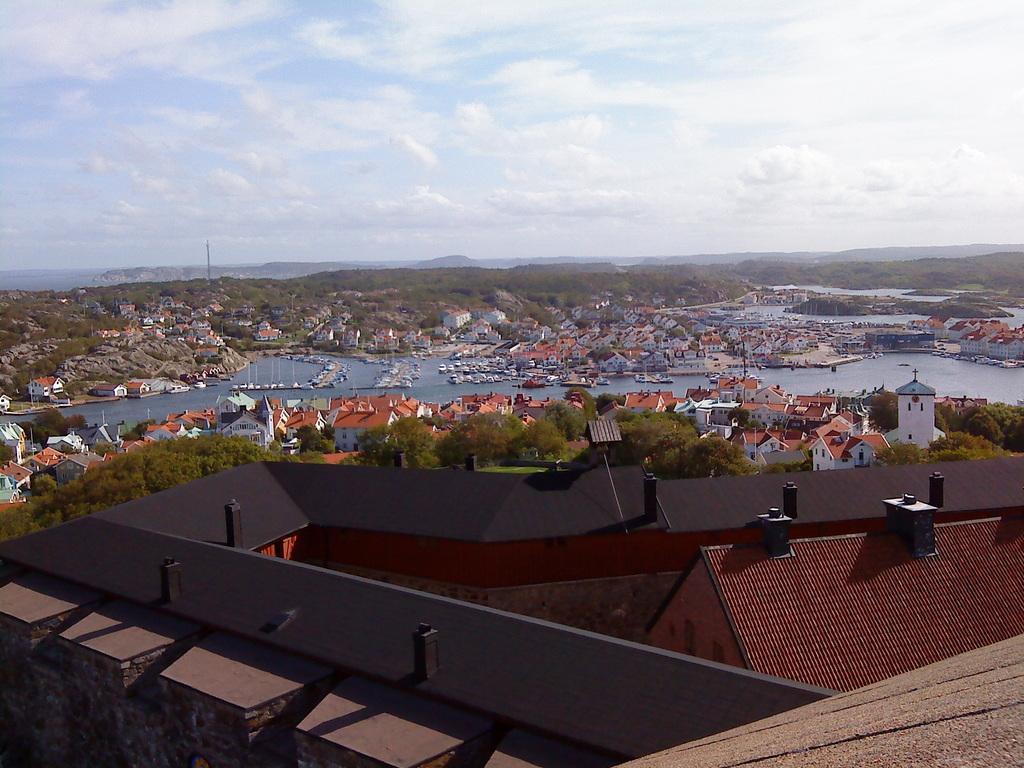Can you describe this image briefly? In this image I can see number of buildings and trees. In the center of this picture I can see the water on which there are boats. In the background I can see the sky. 